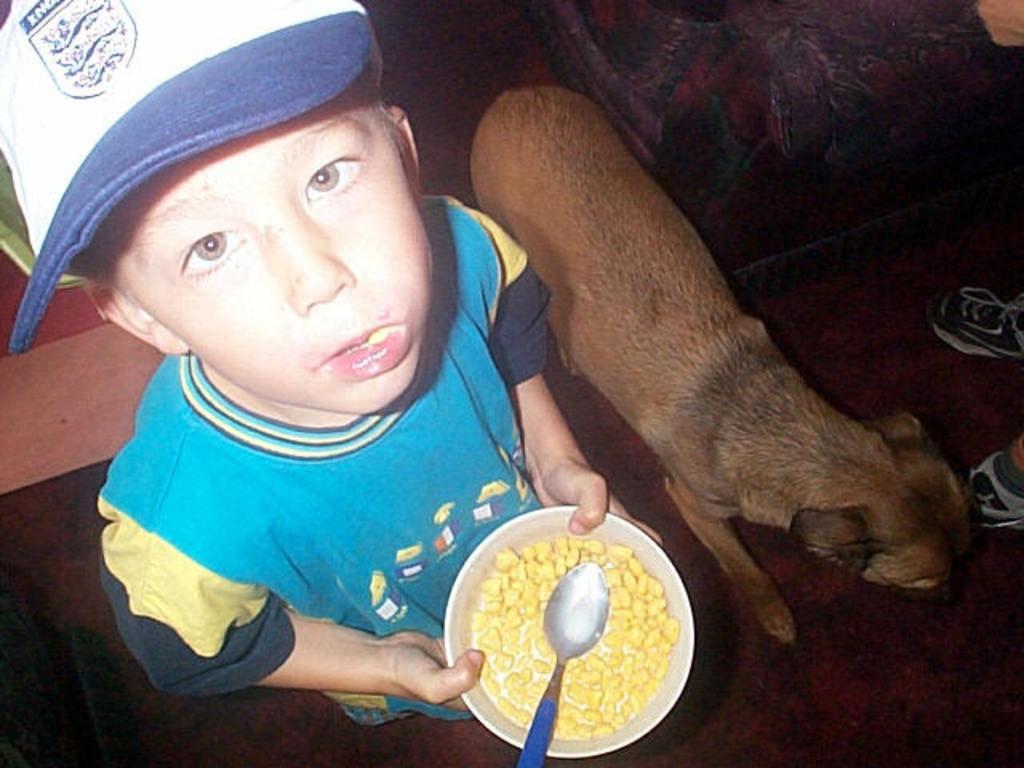Please provide a concise description of this image. As we can see in the image there is dog, a boy wearing cap, sky blue color t shirt and holding bowl. In bowl there is dish. 